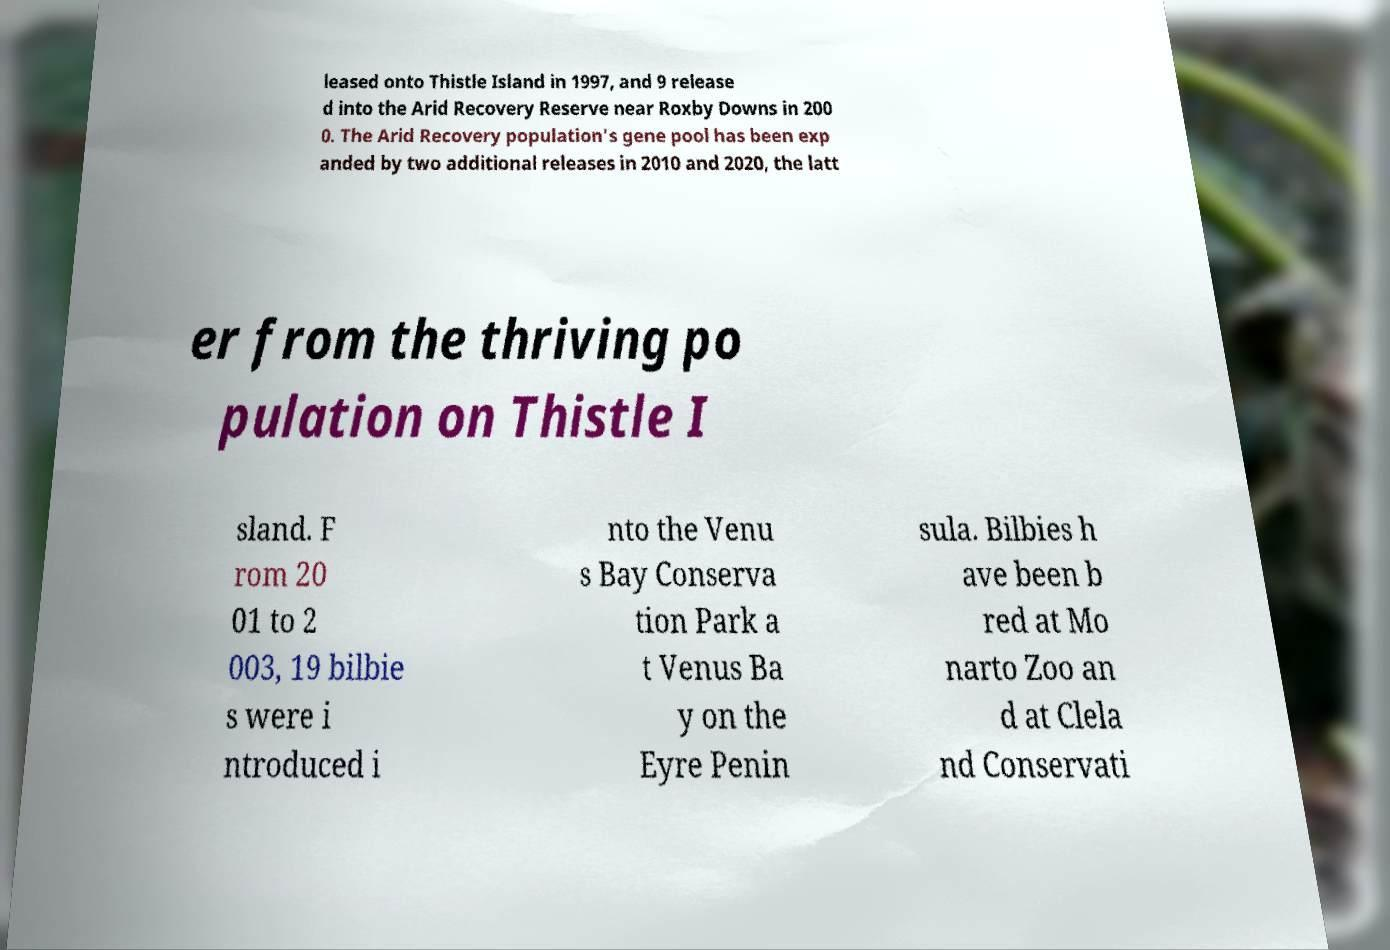Can you accurately transcribe the text from the provided image for me? leased onto Thistle Island in 1997, and 9 release d into the Arid Recovery Reserve near Roxby Downs in 200 0. The Arid Recovery population's gene pool has been exp anded by two additional releases in 2010 and 2020, the latt er from the thriving po pulation on Thistle I sland. F rom 20 01 to 2 003, 19 bilbie s were i ntroduced i nto the Venu s Bay Conserva tion Park a t Venus Ba y on the Eyre Penin sula. Bilbies h ave been b red at Mo narto Zoo an d at Clela nd Conservati 